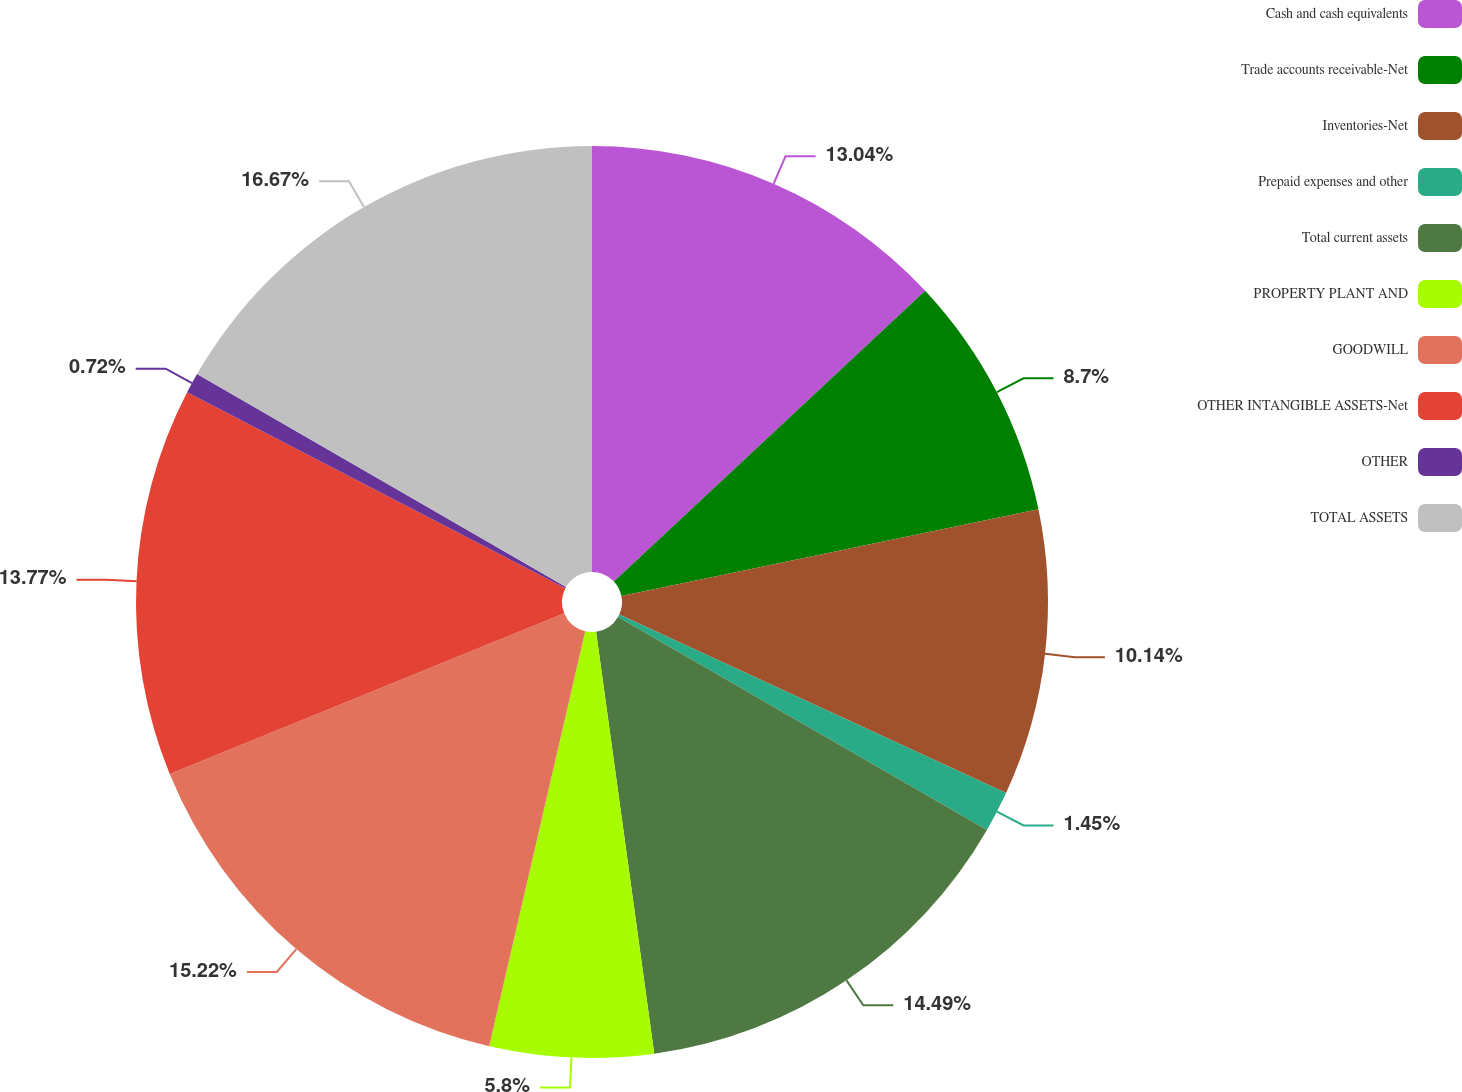<chart> <loc_0><loc_0><loc_500><loc_500><pie_chart><fcel>Cash and cash equivalents<fcel>Trade accounts receivable-Net<fcel>Inventories-Net<fcel>Prepaid expenses and other<fcel>Total current assets<fcel>PROPERTY PLANT AND<fcel>GOODWILL<fcel>OTHER INTANGIBLE ASSETS-Net<fcel>OTHER<fcel>TOTAL ASSETS<nl><fcel>13.04%<fcel>8.7%<fcel>10.14%<fcel>1.45%<fcel>14.49%<fcel>5.8%<fcel>15.22%<fcel>13.77%<fcel>0.72%<fcel>16.67%<nl></chart> 